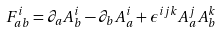Convert formula to latex. <formula><loc_0><loc_0><loc_500><loc_500>F _ { a b } ^ { i } = \partial _ { a } A _ { b } ^ { i } - \partial _ { b } A _ { a } ^ { i } + \epsilon ^ { i j k } A _ { a } ^ { j } A _ { b } ^ { k }</formula> 